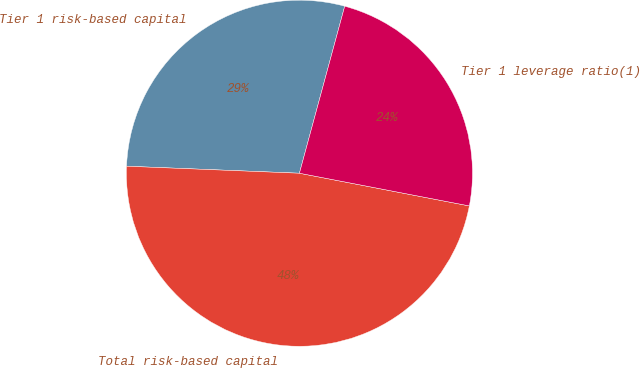<chart> <loc_0><loc_0><loc_500><loc_500><pie_chart><fcel>Tier 1 risk-based capital<fcel>Total risk-based capital<fcel>Tier 1 leverage ratio(1)<nl><fcel>28.57%<fcel>47.62%<fcel>23.81%<nl></chart> 